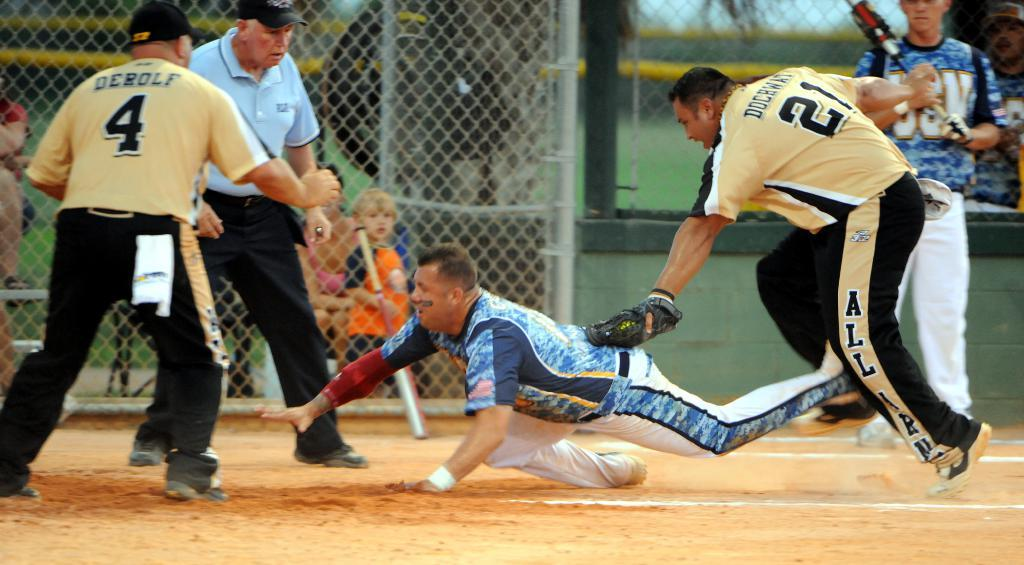<image>
Present a compact description of the photo's key features. Number 4 and 21 try to stop the other player from touching base. 